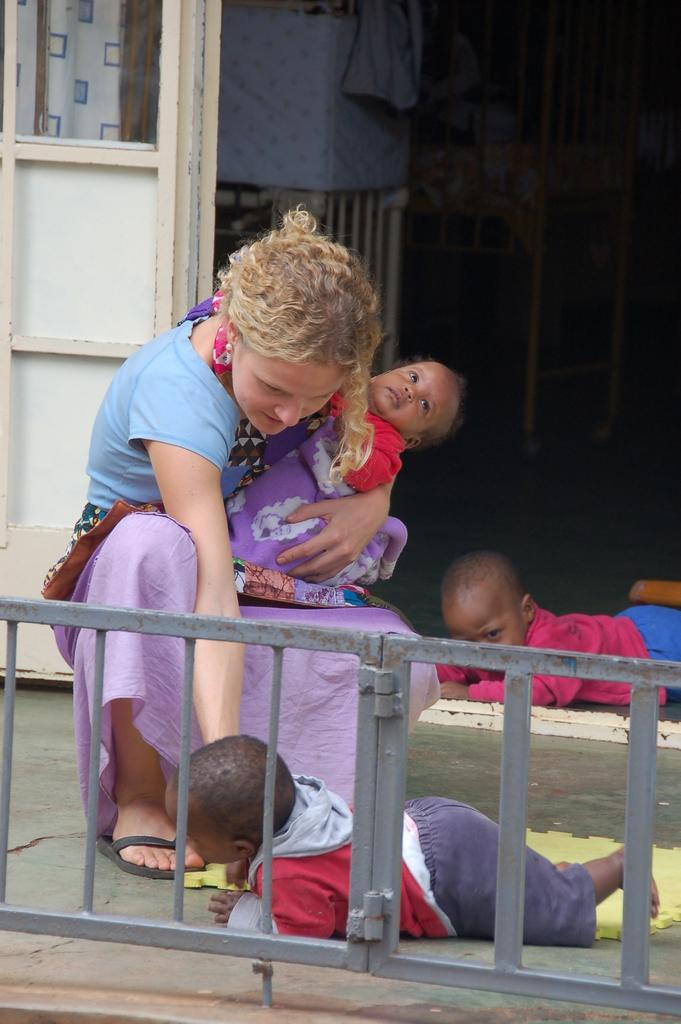Who is the main subject in the image? There is a woman in the image. What is the woman doing in the image? The woman is holding a baby. Are there any other children in the image? Yes, there are two children on the floor. What can be seen in the background of the image? There is fencing and a wooden object in the background of the image. What type of arithmetic problem is the woman solving in the image? There is no indication in the image that the woman is solving an arithmetic problem. Can you see an airplane in the image? No, there is no airplane present in the image. 